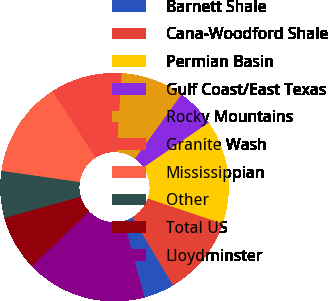Convert chart. <chart><loc_0><loc_0><loc_500><loc_500><pie_chart><fcel>Barnett Shale<fcel>Cana-Woodford Shale<fcel>Permian Basin<fcel>Gulf Coast/East Texas<fcel>Rocky Mountains<fcel>Granite Wash<fcel>Mississippian<fcel>Other<fcel>Total US<fcel>Lloydminster<nl><fcel>4.34%<fcel>11.27%<fcel>14.74%<fcel>5.49%<fcel>8.96%<fcel>10.12%<fcel>13.58%<fcel>6.65%<fcel>7.8%<fcel>17.05%<nl></chart> 